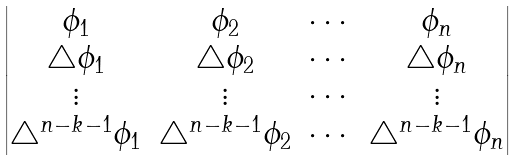<formula> <loc_0><loc_0><loc_500><loc_500>\begin{vmatrix} \phi _ { 1 } & \phi _ { 2 } & \cdots & \phi _ { n } \\ \triangle \phi _ { 1 } & \triangle \phi _ { 2 } & \cdots & \triangle \phi _ { n } \\ \vdots & \vdots & \cdots & \vdots \\ \triangle ^ { n - k - 1 } \phi _ { 1 } & \triangle ^ { n - k - 1 } \phi _ { 2 } & \cdots & \triangle ^ { n - k - 1 } \phi _ { n } \end{vmatrix}</formula> 